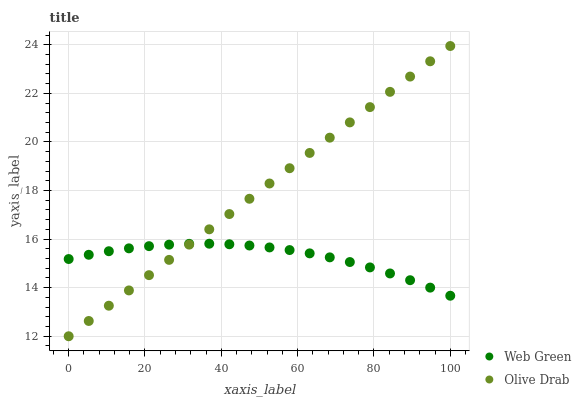Does Web Green have the minimum area under the curve?
Answer yes or no. Yes. Does Olive Drab have the maximum area under the curve?
Answer yes or no. Yes. Does Web Green have the maximum area under the curve?
Answer yes or no. No. Is Olive Drab the smoothest?
Answer yes or no. Yes. Is Web Green the roughest?
Answer yes or no. Yes. Is Web Green the smoothest?
Answer yes or no. No. Does Olive Drab have the lowest value?
Answer yes or no. Yes. Does Web Green have the lowest value?
Answer yes or no. No. Does Olive Drab have the highest value?
Answer yes or no. Yes. Does Web Green have the highest value?
Answer yes or no. No. Does Web Green intersect Olive Drab?
Answer yes or no. Yes. Is Web Green less than Olive Drab?
Answer yes or no. No. Is Web Green greater than Olive Drab?
Answer yes or no. No. 